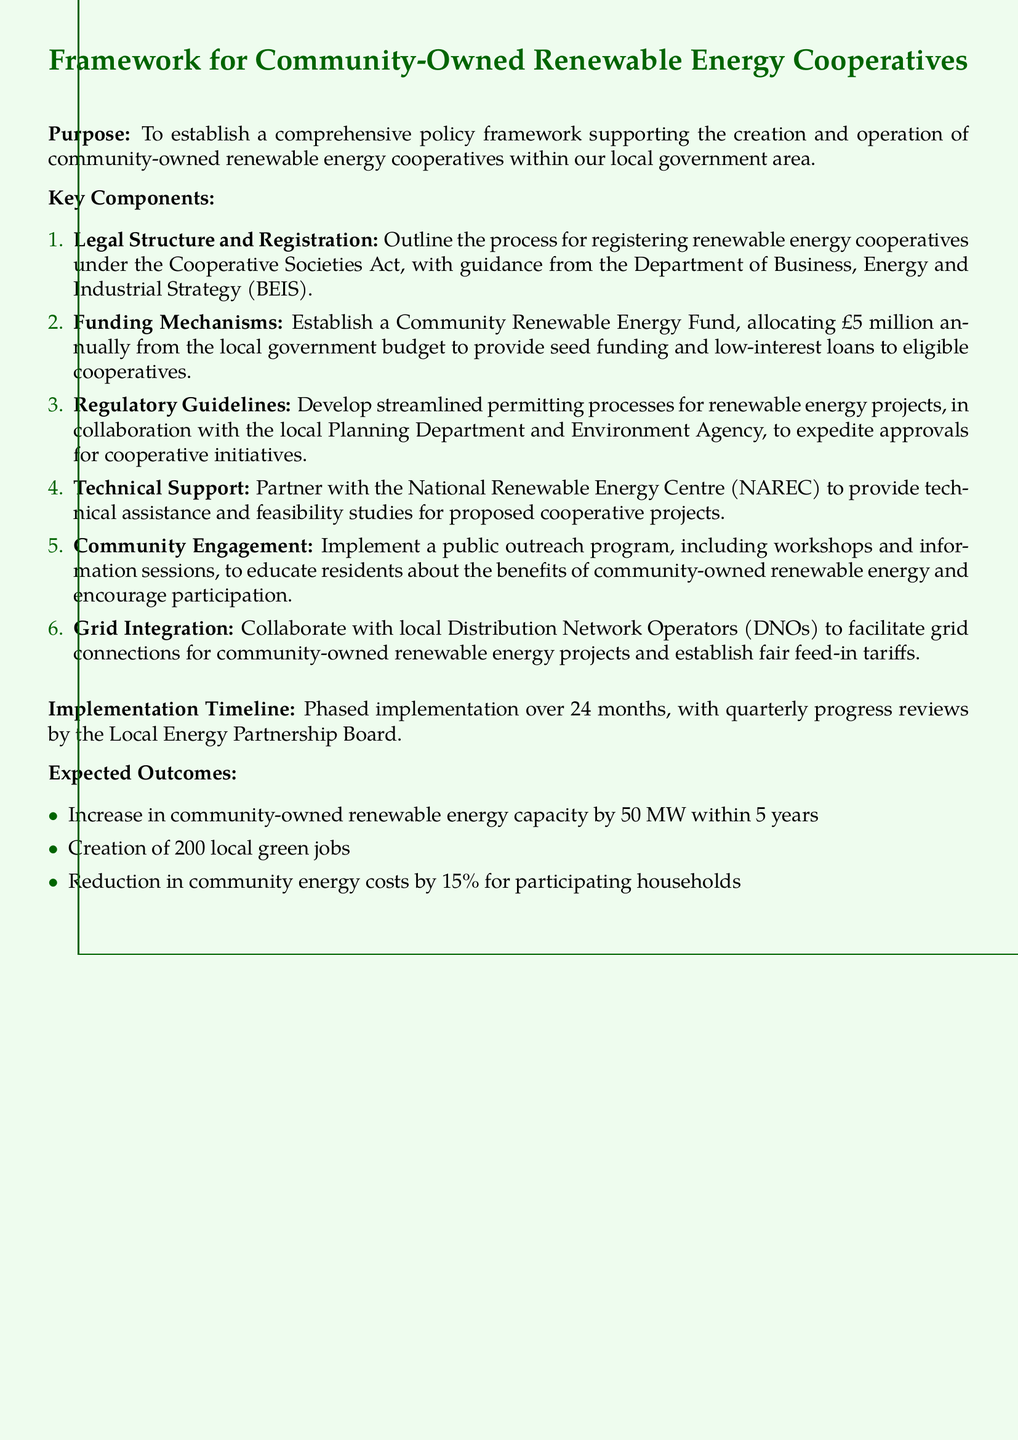what is the annual allocation for the Community Renewable Energy Fund? The document states that the annual allocation for the Community Renewable Energy Fund is £5 million.
Answer: £5 million how many local green jobs are expected to be created? The expected outcome mentions the creation of 200 local green jobs.
Answer: 200 which government department provides guidance for registering renewable energy cooperatives? The document refers to the Department of Business, Energy and Industrial Strategy (BEIS) as providing guidance.
Answer: BEIS what is the expected increase in community-owned renewable energy capacity within 5 years? The document indicates an expected increase of 50 MW in community-owned renewable energy capacity.
Answer: 50 MW what is the implementation timeline for the framework? The implementation timeline specified in the document is over 24 months.
Answer: 24 months which organization is partnered with for technical support? The National Renewable Energy Centre (NAREC) is the organization partnered with for technical support.
Answer: NAREC what percentage reduction in community energy costs is expected for participating households? The expected reduction in community energy costs for participating households is 15%.
Answer: 15% how often will progress reviews take place? The document states that progress reviews will take place quarterly.
Answer: quarterly 